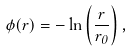Convert formula to latex. <formula><loc_0><loc_0><loc_500><loc_500>\phi ( { r } ) = - \ln \left ( \frac { r } { r _ { 0 } } \right ) ,</formula> 